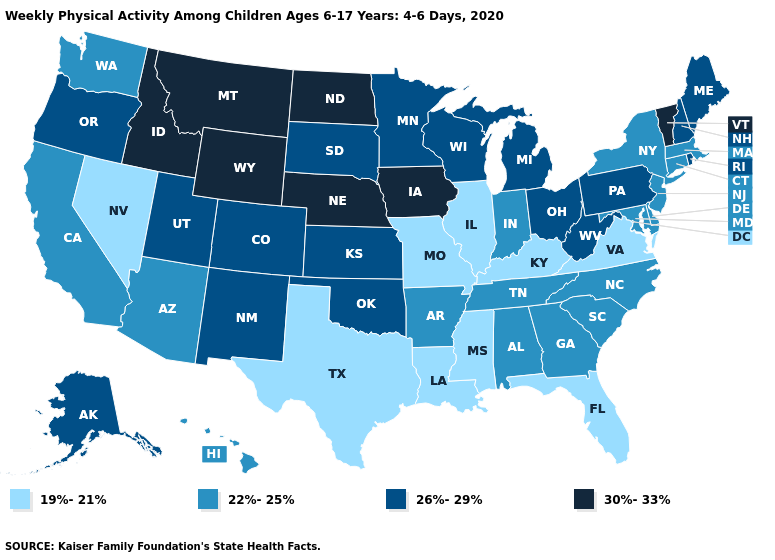Is the legend a continuous bar?
Answer briefly. No. What is the value of Arizona?
Give a very brief answer. 22%-25%. What is the value of New York?
Give a very brief answer. 22%-25%. How many symbols are there in the legend?
Short answer required. 4. What is the value of Louisiana?
Write a very short answer. 19%-21%. What is the value of Washington?
Give a very brief answer. 22%-25%. What is the lowest value in states that border Vermont?
Write a very short answer. 22%-25%. What is the lowest value in states that border Minnesota?
Write a very short answer. 26%-29%. Is the legend a continuous bar?
Short answer required. No. Among the states that border California , which have the highest value?
Short answer required. Oregon. Name the states that have a value in the range 30%-33%?
Write a very short answer. Idaho, Iowa, Montana, Nebraska, North Dakota, Vermont, Wyoming. How many symbols are there in the legend?
Keep it brief. 4. Among the states that border Oklahoma , which have the lowest value?
Write a very short answer. Missouri, Texas. Does Florida have a lower value than North Carolina?
Give a very brief answer. Yes. Which states have the highest value in the USA?
Short answer required. Idaho, Iowa, Montana, Nebraska, North Dakota, Vermont, Wyoming. 